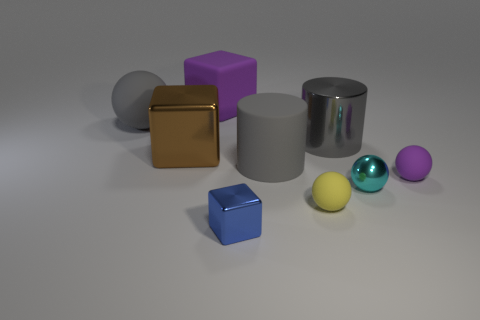The gray thing on the right side of the large object that is in front of the shiny block to the left of the small blue thing is made of what material?
Offer a terse response. Metal. Are there an equal number of tiny yellow matte things that are in front of the big metal cube and large purple metal cylinders?
Provide a short and direct response. No. Are the purple object in front of the big gray rubber ball and the large cube that is in front of the purple matte block made of the same material?
Offer a terse response. No. What number of objects are either blue rubber cylinders or things that are to the right of the gray shiny cylinder?
Provide a succinct answer. 2. Is there a tiny blue object of the same shape as the brown thing?
Make the answer very short. Yes. What is the size of the shiny thing left of the metallic block that is right of the large matte object behind the big ball?
Keep it short and to the point. Large. Are there an equal number of gray matte cylinders that are behind the purple block and cyan metal balls behind the large gray rubber cylinder?
Make the answer very short. Yes. There is a gray cylinder that is the same material as the purple sphere; what size is it?
Offer a terse response. Large. What is the color of the big rubber block?
Provide a succinct answer. Purple. How many big matte balls are the same color as the large rubber cylinder?
Your answer should be compact. 1. 